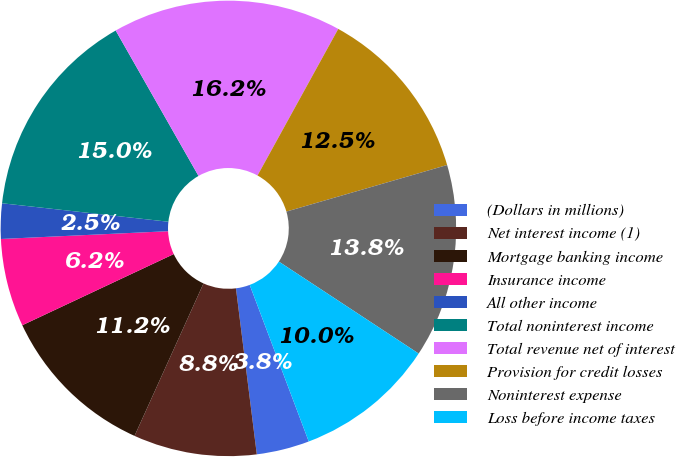Convert chart. <chart><loc_0><loc_0><loc_500><loc_500><pie_chart><fcel>(Dollars in millions)<fcel>Net interest income (1)<fcel>Mortgage banking income<fcel>Insurance income<fcel>All other income<fcel>Total noninterest income<fcel>Total revenue net of interest<fcel>Provision for credit losses<fcel>Noninterest expense<fcel>Loss before income taxes<nl><fcel>3.75%<fcel>8.75%<fcel>11.25%<fcel>6.25%<fcel>2.5%<fcel>15.0%<fcel>16.25%<fcel>12.5%<fcel>13.75%<fcel>10.0%<nl></chart> 